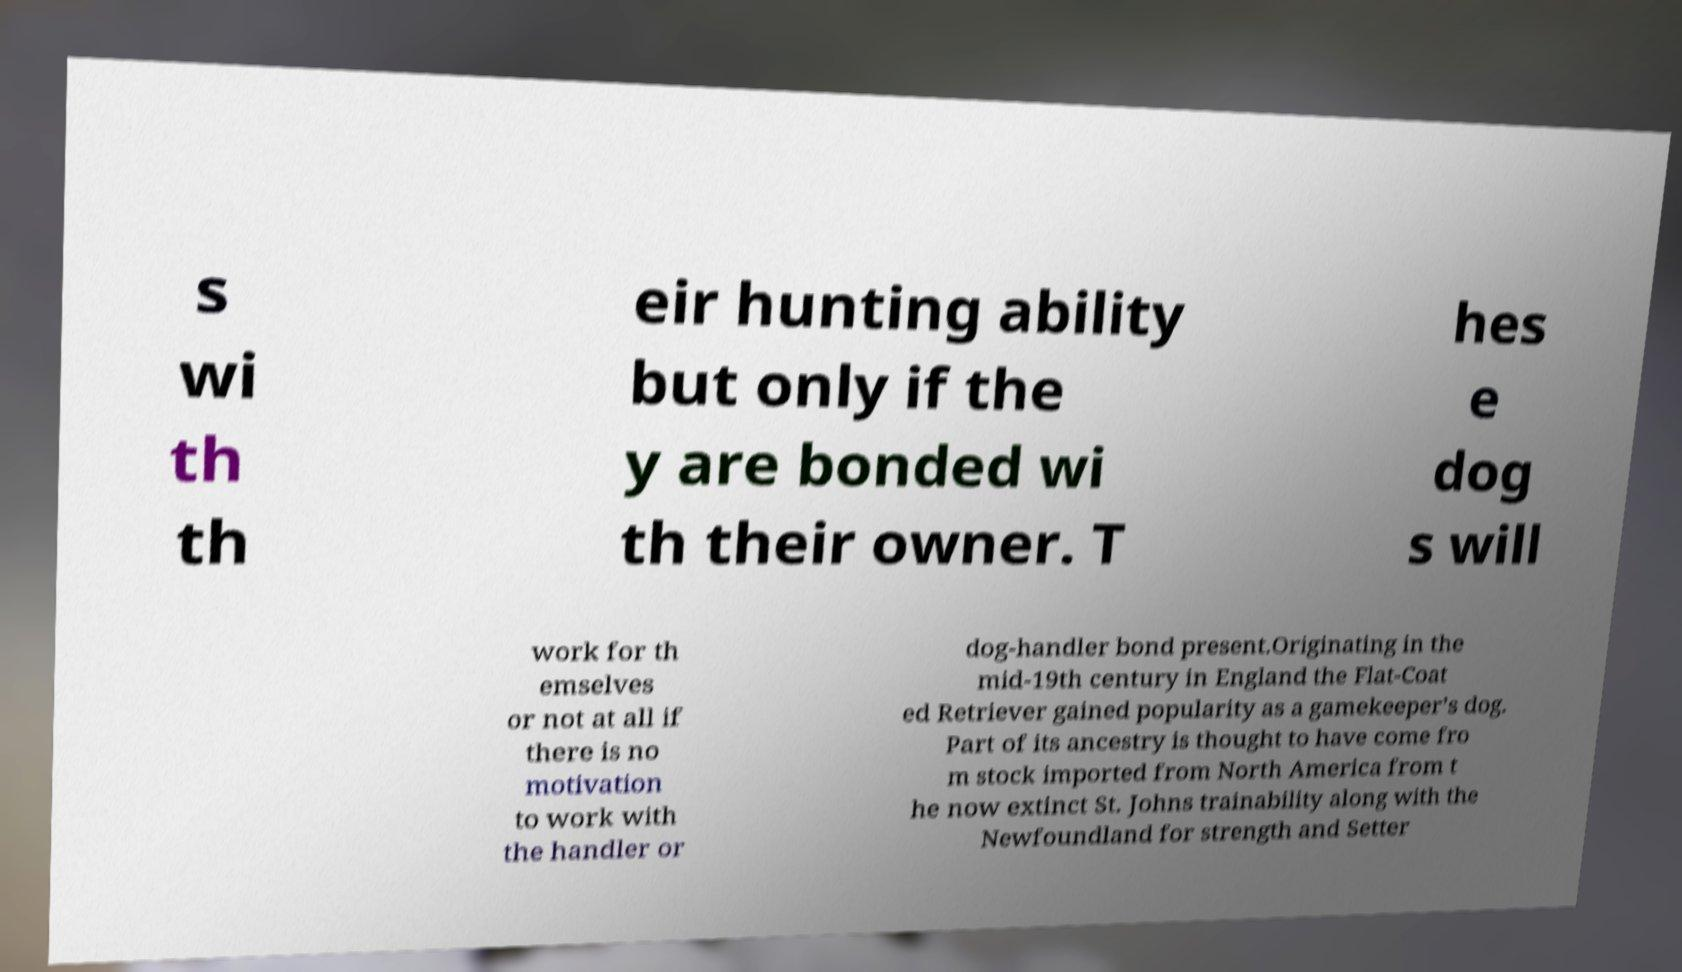For documentation purposes, I need the text within this image transcribed. Could you provide that? s wi th th eir hunting ability but only if the y are bonded wi th their owner. T hes e dog s will work for th emselves or not at all if there is no motivation to work with the handler or dog-handler bond present.Originating in the mid-19th century in England the Flat-Coat ed Retriever gained popularity as a gamekeeper’s dog. Part of its ancestry is thought to have come fro m stock imported from North America from t he now extinct St. Johns trainability along with the Newfoundland for strength and Setter 